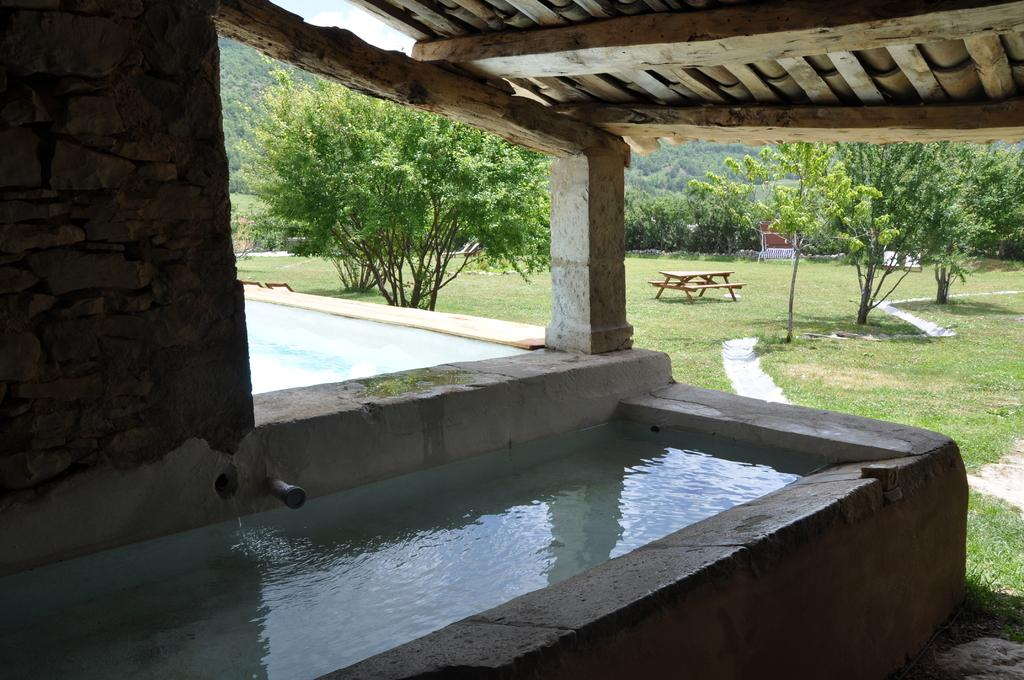What is contained in the container in the image? There is water in a container in the image. What can be seen in the background of the image? The sky is visible in the background of the image. What type of vegetation is present in the image? There is grass and trees in the image. What type of furniture is in the image? There is a picnic table and chairs in the image. What is the purpose of the wall in the image? The wall serves as a boundary or barrier in the image. What type of pain is the person experiencing in the image? There is no person experiencing pain in the image. What is the best way to reach the location depicted in the image? The image does not provide information about the location or the best way to reach it. 